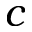<formula> <loc_0><loc_0><loc_500><loc_500>c</formula> 